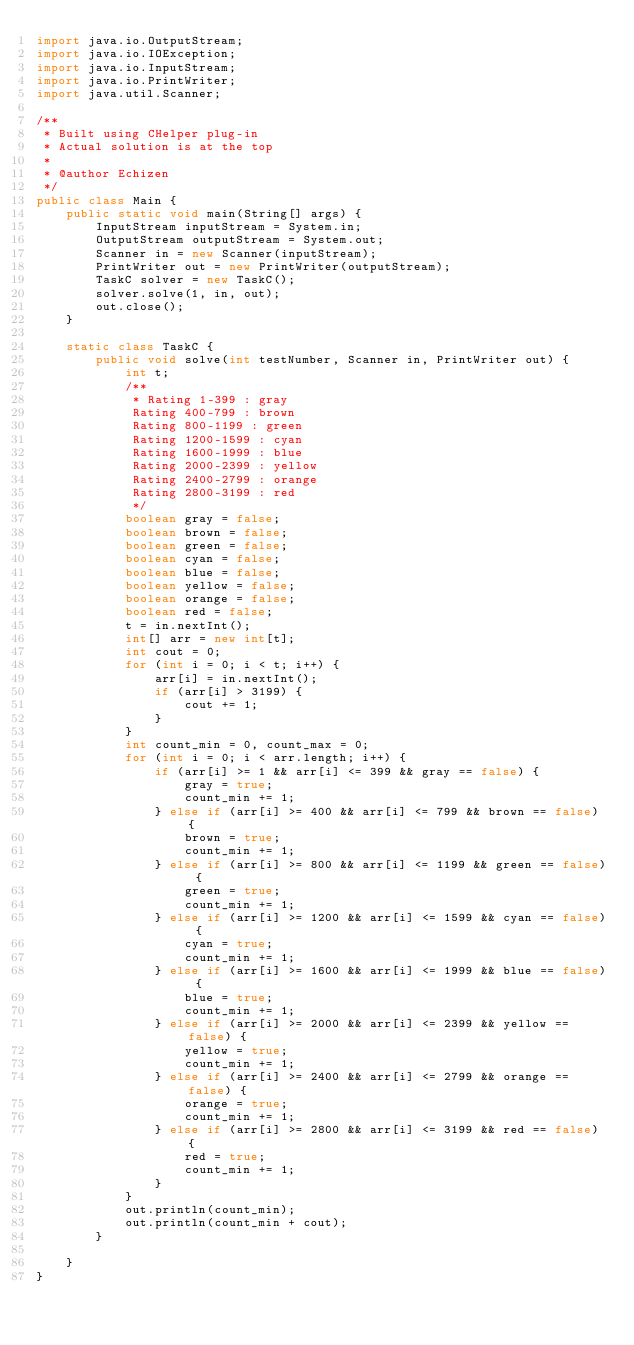Convert code to text. <code><loc_0><loc_0><loc_500><loc_500><_Java_>import java.io.OutputStream;
import java.io.IOException;
import java.io.InputStream;
import java.io.PrintWriter;
import java.util.Scanner;

/**
 * Built using CHelper plug-in
 * Actual solution is at the top
 *
 * @author Echizen
 */
public class Main {
    public static void main(String[] args) {
        InputStream inputStream = System.in;
        OutputStream outputStream = System.out;
        Scanner in = new Scanner(inputStream);
        PrintWriter out = new PrintWriter(outputStream);
        TaskC solver = new TaskC();
        solver.solve(1, in, out);
        out.close();
    }

    static class TaskC {
        public void solve(int testNumber, Scanner in, PrintWriter out) {
            int t;
            /**
             * Rating 1-399 : gray
             Rating 400-799 : brown
             Rating 800-1199 : green
             Rating 1200-1599 : cyan
             Rating 1600-1999 : blue
             Rating 2000-2399 : yellow
             Rating 2400-2799 : orange
             Rating 2800-3199 : red
             */
            boolean gray = false;
            boolean brown = false;
            boolean green = false;
            boolean cyan = false;
            boolean blue = false;
            boolean yellow = false;
            boolean orange = false;
            boolean red = false;
            t = in.nextInt();
            int[] arr = new int[t];
            int cout = 0;
            for (int i = 0; i < t; i++) {
                arr[i] = in.nextInt();
                if (arr[i] > 3199) {
                    cout += 1;
                }
            }
            int count_min = 0, count_max = 0;
            for (int i = 0; i < arr.length; i++) {
                if (arr[i] >= 1 && arr[i] <= 399 && gray == false) {
                    gray = true;
                    count_min += 1;
                } else if (arr[i] >= 400 && arr[i] <= 799 && brown == false) {
                    brown = true;
                    count_min += 1;
                } else if (arr[i] >= 800 && arr[i] <= 1199 && green == false) {
                    green = true;
                    count_min += 1;
                } else if (arr[i] >= 1200 && arr[i] <= 1599 && cyan == false) {
                    cyan = true;
                    count_min += 1;
                } else if (arr[i] >= 1600 && arr[i] <= 1999 && blue == false) {
                    blue = true;
                    count_min += 1;
                } else if (arr[i] >= 2000 && arr[i] <= 2399 && yellow == false) {
                    yellow = true;
                    count_min += 1;
                } else if (arr[i] >= 2400 && arr[i] <= 2799 && orange == false) {
                    orange = true;
                    count_min += 1;
                } else if (arr[i] >= 2800 && arr[i] <= 3199 && red == false) {
                    red = true;
                    count_min += 1;
                }
            }
            out.println(count_min);
            out.println(count_min + cout);
        }

    }
}

</code> 